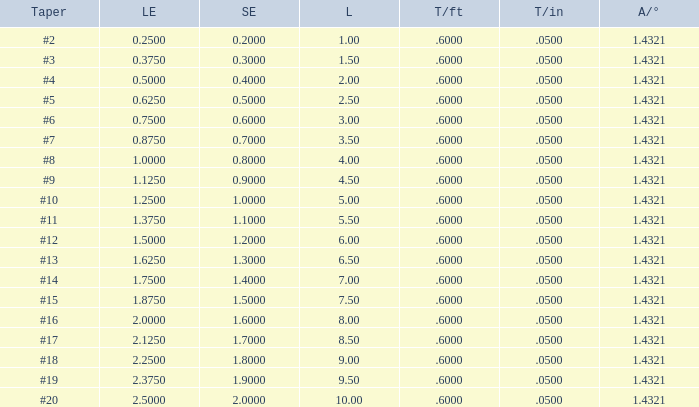Which Large end has a Taper/ft smaller than 0.6000000000000001? 19.0. 